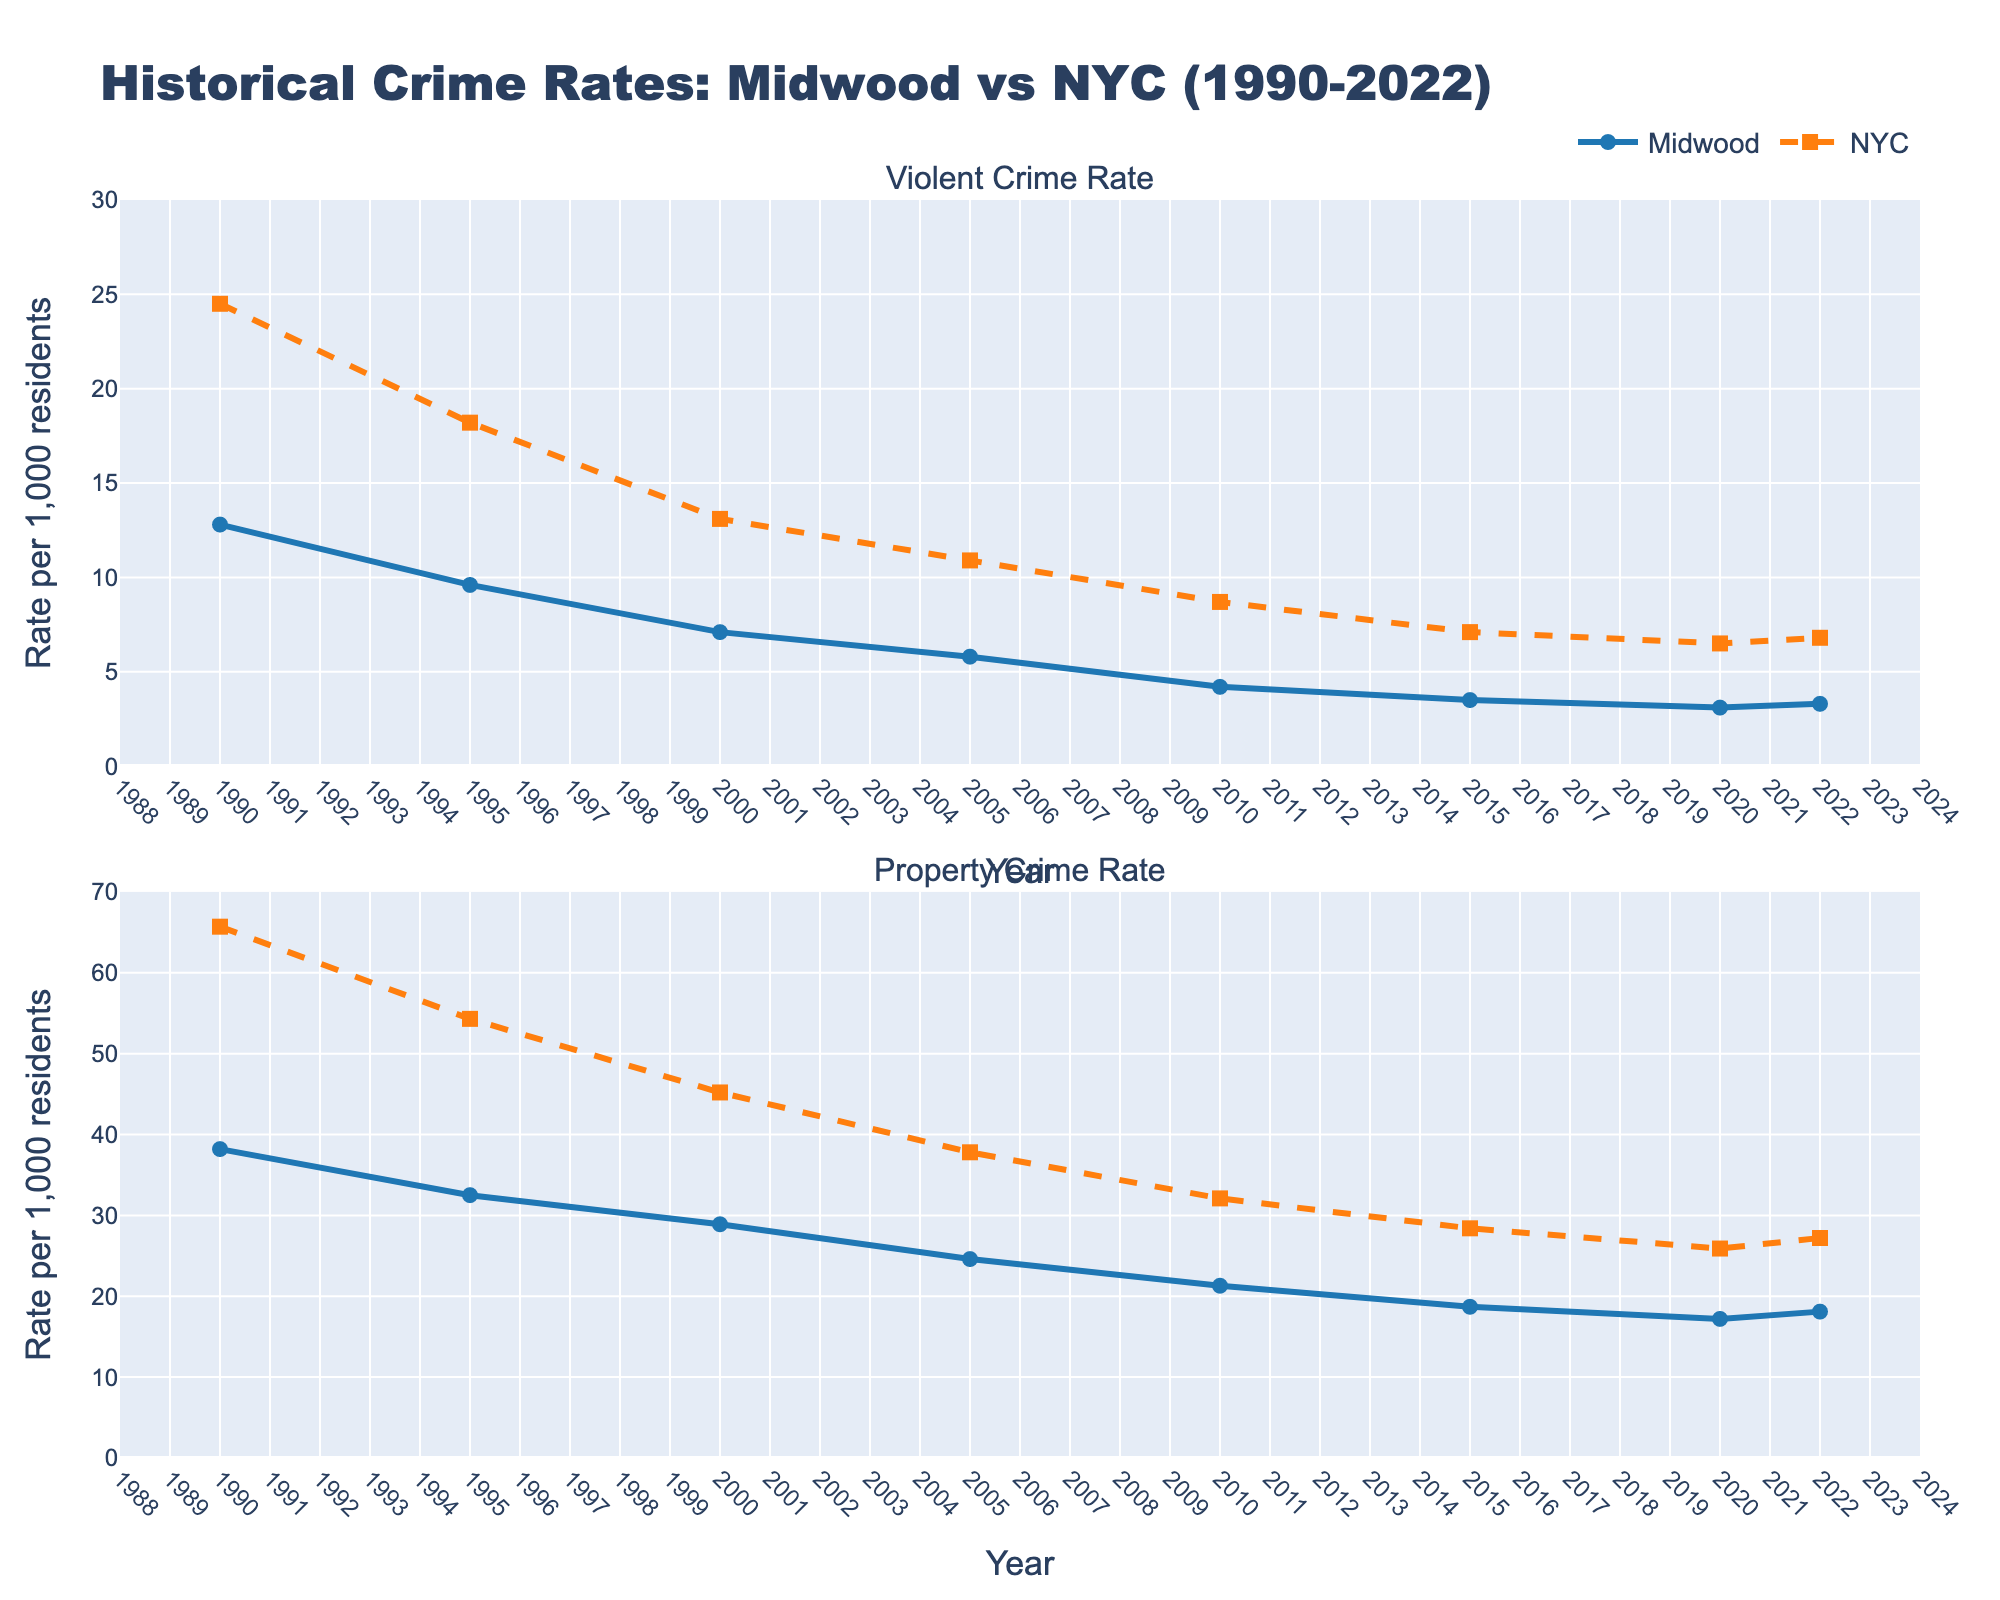What's the trend in violent crime rates in Midwood from 1990 to 2022? Visually follow the blue line in the top subplot labeled "Violent Crime Rate" for Midwood. Notice that it generally decreases over time from 12.8 in 1990 to 3.3 in 2022 with minor fluctuations.
Answer: Decreasing Which has a higher property crime rate in 2010, Midwood or NYC? Check the values for 2010 in the bottom subplot, where Midwood is marked with a blue circle, and NYC with an orange square. The Midwood rate is 21.3, while the NYC rate is 32.1.
Answer: NYC What is the difference in violent crime rates between NYC and Midwood in 1995? Locate the 1995 data points in the top subplot. NYC's rate is 18.2, and Midwood's is 9.6. Subtract Midwood's rate from NYC's: 18.2 - 9.6.
Answer: 8.6 In which year did Midwood have its lowest property crime rate? Look for the lowest point in the blue line with circles in the bottom subplot. The minimum occurs at 2020 with a value of 17.2.
Answer: 2020 How much did the property crime rate in Midwood decrease from 1990 to 2005? Check the property crime rates for Midwood at 1990 and 2005 in the bottom subplot. The 1990 rate is 38.2 and the 2005 rate is 24.6. Subtract 24.6 from 38.2.
Answer: 13.6 Compare the violent crime rates in 2020 for Midwood and NYC. Which is lower? Locate the year 2020 in the top subplot. Midwood's rate is marked with a blue circle at 3.1, and NYC's with an orange square at 6.5.
Answer: Midwood What's the general trend in property crime rates in NYC from 1990 to 2022? Follow the orange dashed line with squares in the bottom subplot. Notice that the line consistently falls from 65.7 in 1990 to 27.2 in 2022.
Answer: Decreasing From 2015 to 2022, how did the violent crime rate in NYC change? Identify the data points for NYC in 2015 and 2022 in the top subplot. The values are 7.1 in 2015 and 6.8 in 2022. Calculate the difference: 7.1 - 6.8.
Answer: Decreased by 0.3 What year did Midwood have a lower violent crime rate than NYC for the first time? Compare the points for each year from 1990 onward in the top subplot. Midwood's rate first drops below NYC's in 2000 (7.1 vs 13.1).
Answer: 2000 